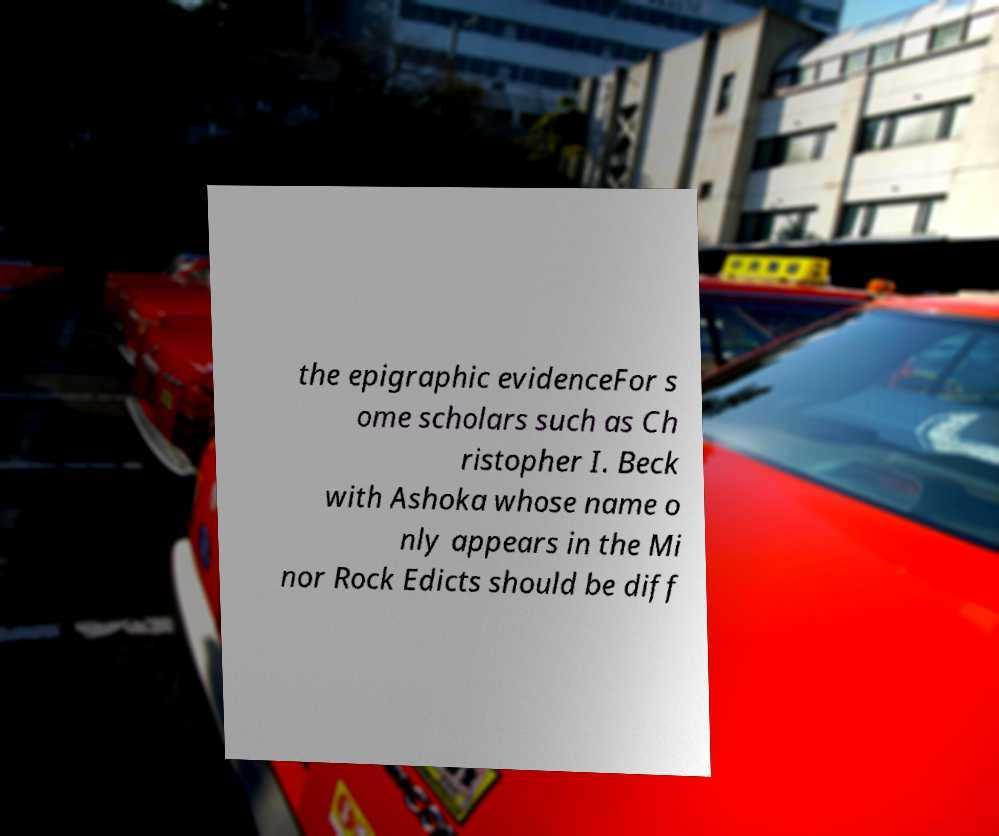Can you read and provide the text displayed in the image?This photo seems to have some interesting text. Can you extract and type it out for me? the epigraphic evidenceFor s ome scholars such as Ch ristopher I. Beck with Ashoka whose name o nly appears in the Mi nor Rock Edicts should be diff 